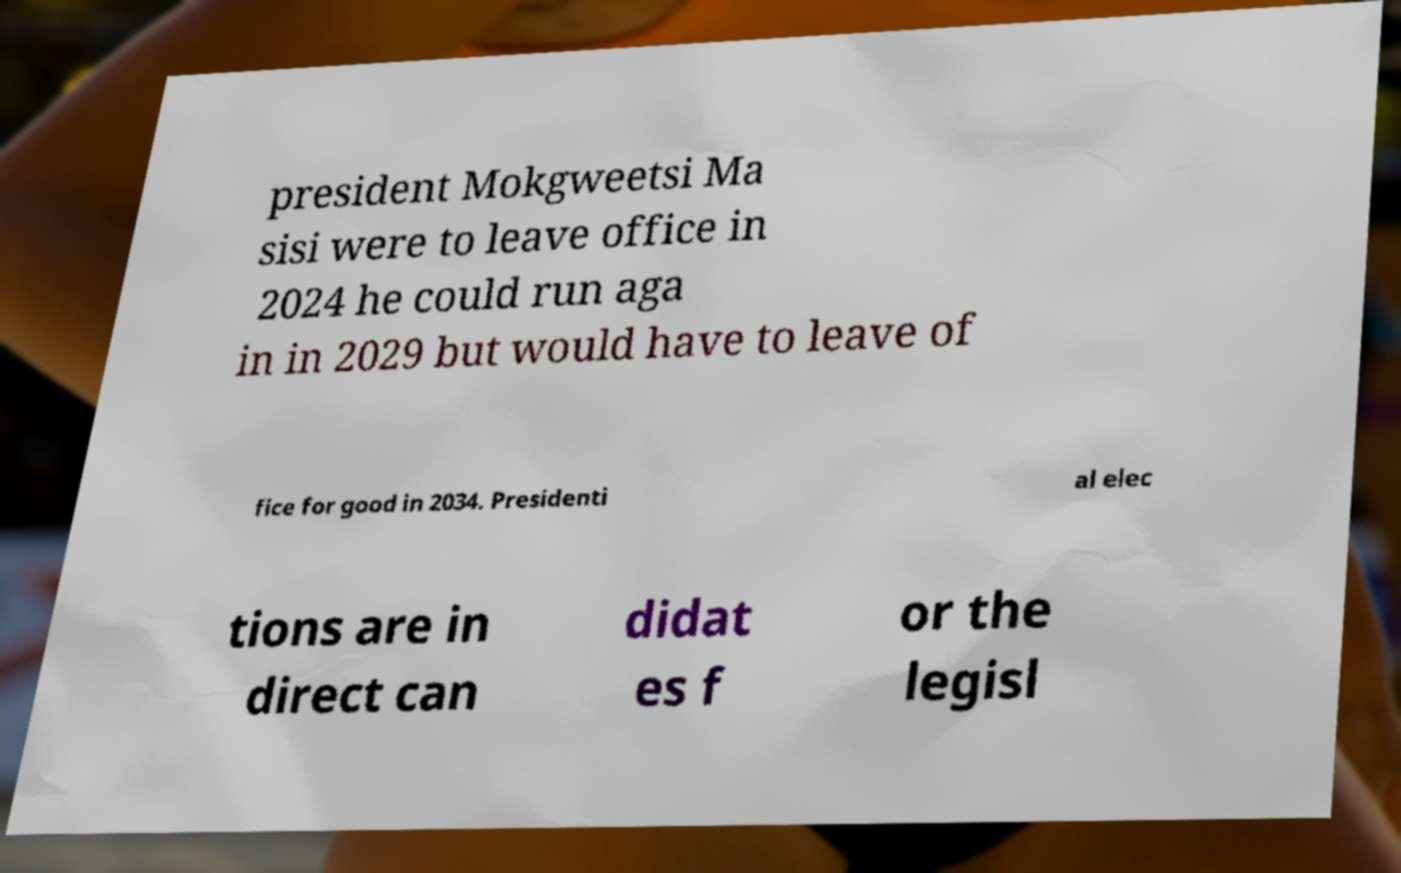Please identify and transcribe the text found in this image. president Mokgweetsi Ma sisi were to leave office in 2024 he could run aga in in 2029 but would have to leave of fice for good in 2034. Presidenti al elec tions are in direct can didat es f or the legisl 